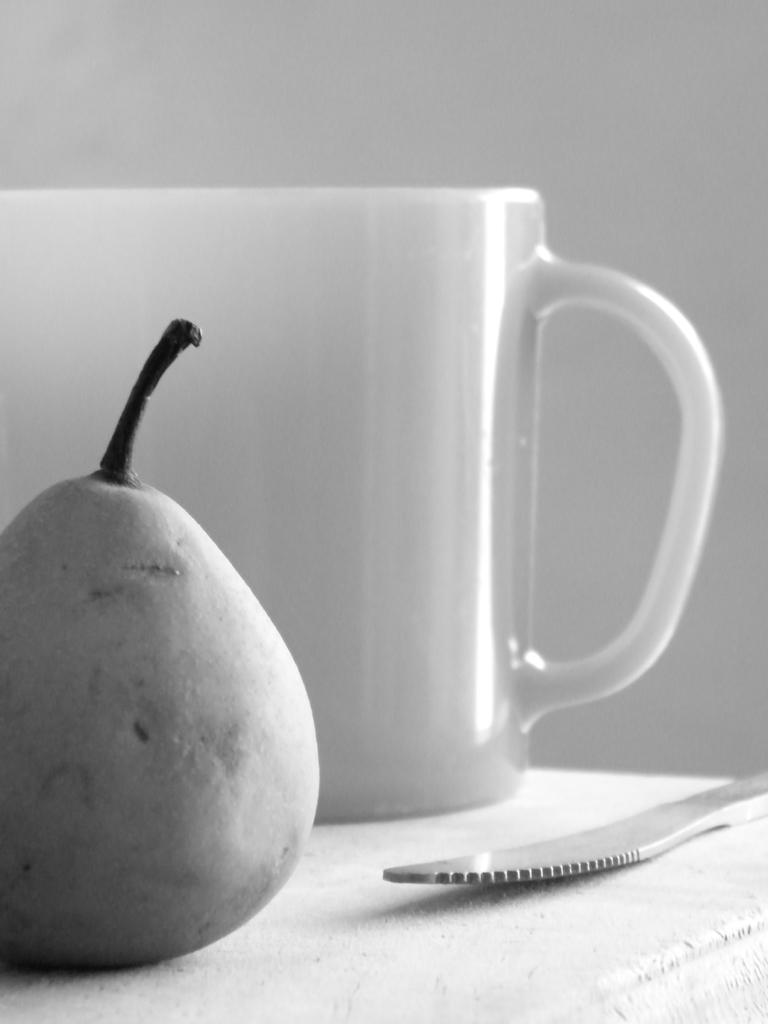What type of objects can be seen in the image? There are pearls, a cup, and a knife in the image. Where are these objects located? All objects are placed on a table. What might the cup be used for? The cup could be used for holding a beverage or other liquid. What is the purpose of the knife in the image? The knife could be used for cutting or slicing food. How does the body of the turkey look in the image? There is no turkey present in the image, so it is not possible to describe its body. 